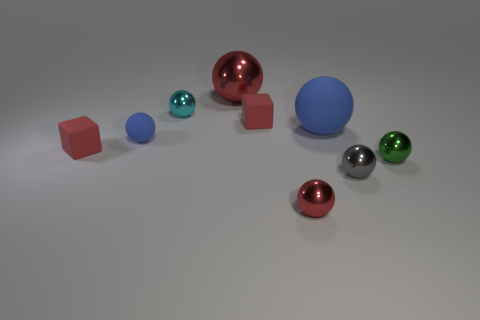Are there any green metallic objects on the right side of the matte cube that is on the left side of the small block right of the small cyan metallic sphere?
Your answer should be very brief. Yes. There is a tiny blue ball; are there any big red shiny things left of it?
Ensure brevity in your answer.  No. Are there any other rubber balls of the same color as the large matte sphere?
Offer a very short reply. Yes. What number of large objects are either red rubber spheres or matte balls?
Give a very brief answer. 1. Is the material of the blue sphere that is on the right side of the tiny cyan object the same as the green object?
Your answer should be very brief. No. The blue object that is on the left side of the matte thing that is on the right side of the red metallic thing that is to the right of the big red metallic thing is what shape?
Provide a succinct answer. Sphere. What number of yellow things are rubber objects or large shiny spheres?
Ensure brevity in your answer.  0. Are there the same number of tiny red things that are left of the large red metal ball and large matte things that are on the right side of the tiny gray metal sphere?
Your response must be concise. No. There is a metal object to the right of the gray thing; is its shape the same as the small red matte thing in front of the big matte ball?
Provide a short and direct response. No. Are there any other things that have the same shape as the small blue object?
Provide a succinct answer. Yes. 